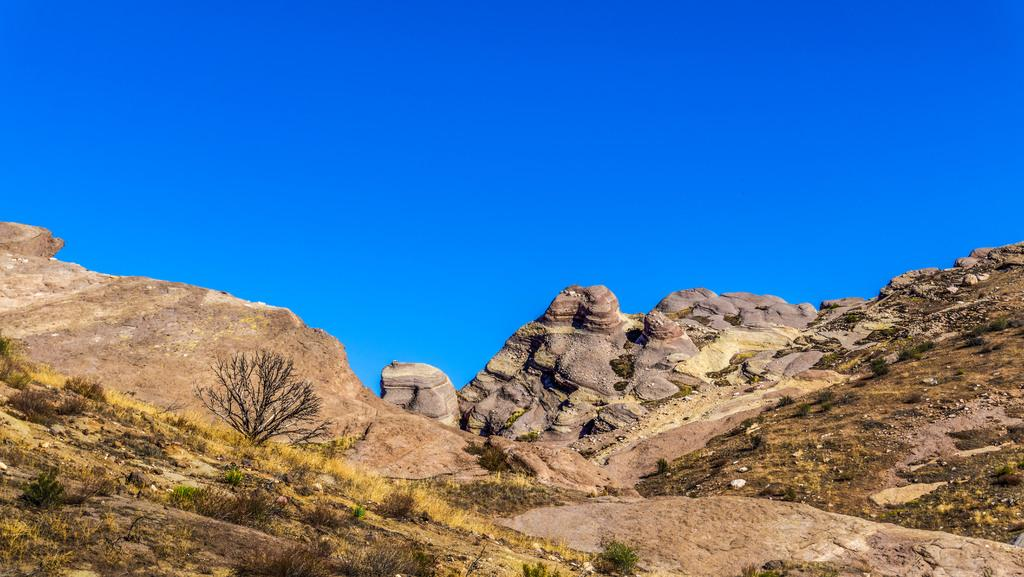What type of natural formation can be seen in the image? There are mountains in the image. What other objects can be seen in the image? There are rocks and trees visible in the image. Where are the trees located in the image? The trees are at the bottom of the image. What is visible at the top of the image? The sky is visible at the top of the image. What type of butter is being used to sculpt the mountains in the image? There is no butter present in the image, and the mountains are natural formations, not sculptures. 